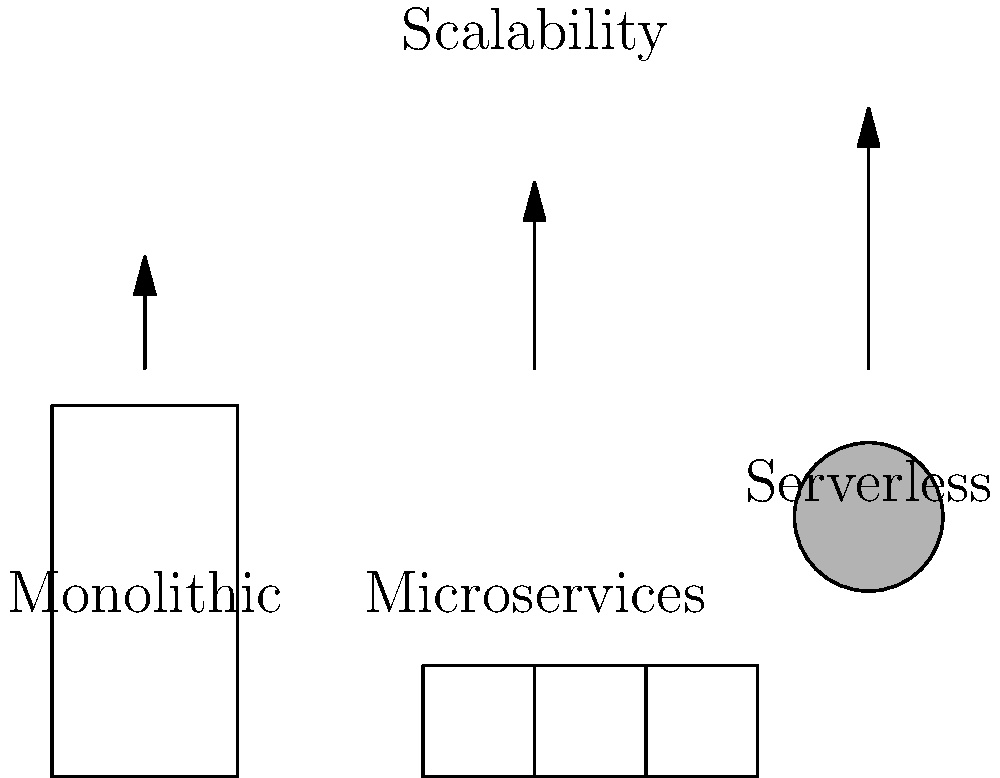Based on the software architecture diagrams shown, which architecture provides the highest level of scalability and why is it particularly advantageous for developing user-friendly and bug-free applications? To answer this question, let's analyze each architecture:

1. Monolithic Architecture:
   - Single, tightly-coupled unit
   - Limited scalability (shortest arrow)
   - Difficult to update or modify without affecting the entire system

2. Microservices Architecture:
   - Composed of small, independent services
   - Better scalability than monolithic (longer arrow)
   - Easier to update and maintain individual components

3. Serverless Architecture:
   - Highest level of scalability (longest arrow)
   - Automatic scaling based on demand
   - No need to manage infrastructure

For developing user-friendly and bug-free applications:

1. Serverless architecture allows for easier updates and bug fixes without disrupting the entire system.
2. It enables rapid scaling to handle sudden increases in user traffic, maintaining a smooth user experience.
3. Developers can focus on writing quality code rather than managing infrastructure, reducing the likelihood of bugs.
4. Individual functions can be tested and optimized independently, improving overall application reliability.
5. Automatic scaling ensures consistent performance, contributing to a better user experience.

Therefore, the serverless architecture provides the highest level of scalability and offers significant advantages for developing user-friendly and bug-free applications.
Answer: Serverless architecture; it offers automatic scaling, easier updates, and allows developers to focus on code quality rather than infrastructure management. 